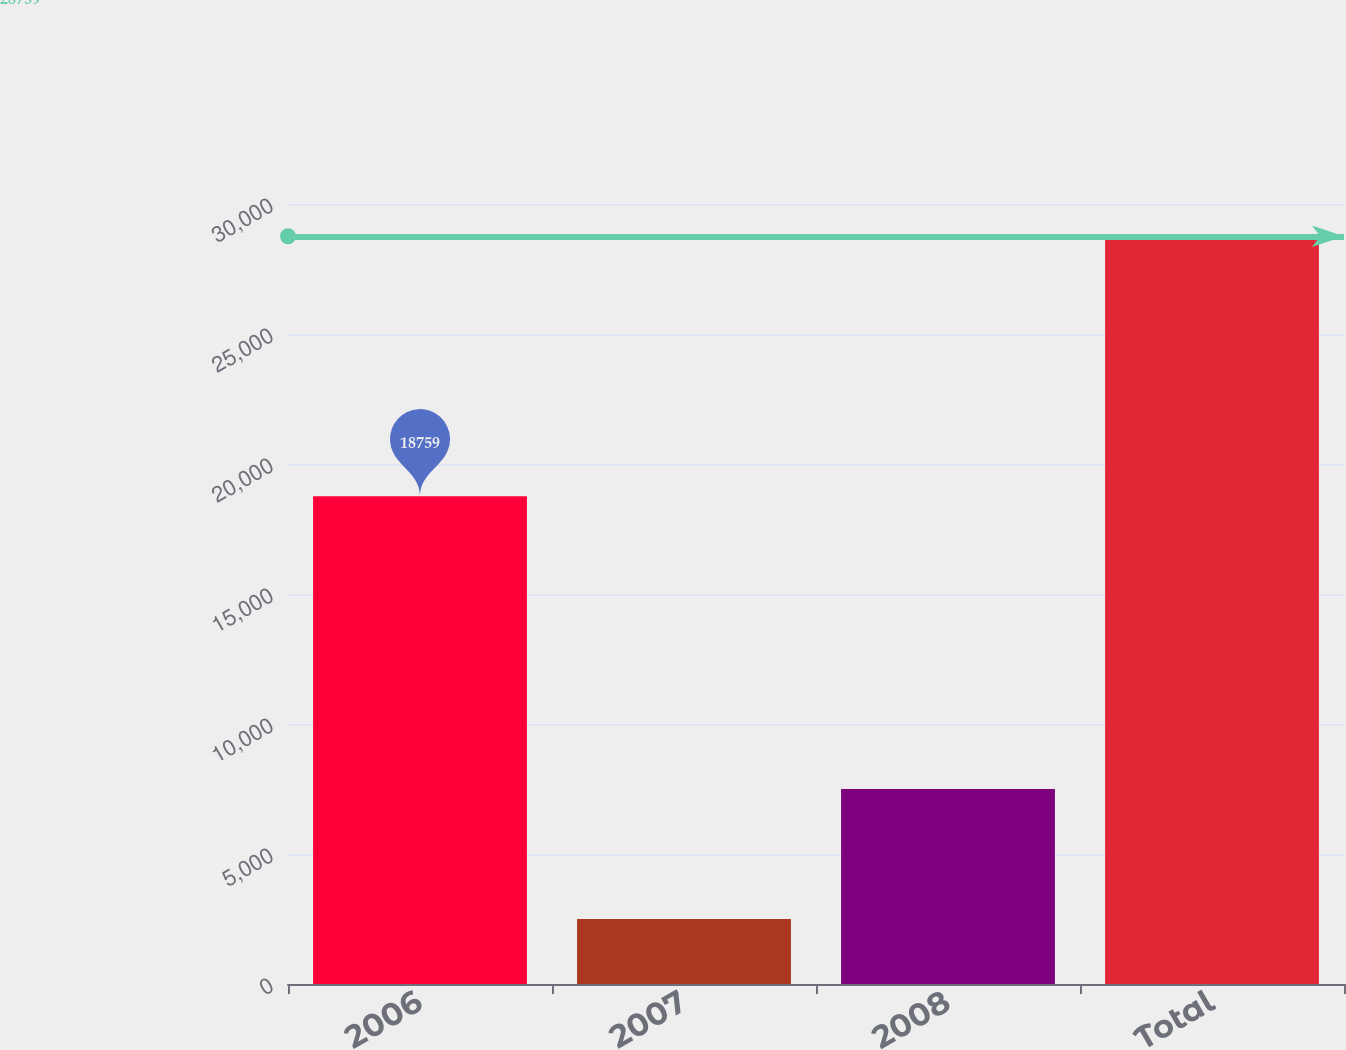<chart> <loc_0><loc_0><loc_500><loc_500><bar_chart><fcel>2006<fcel>2007<fcel>2008<fcel>Total<nl><fcel>18759<fcel>2500<fcel>7500<fcel>28759<nl></chart> 